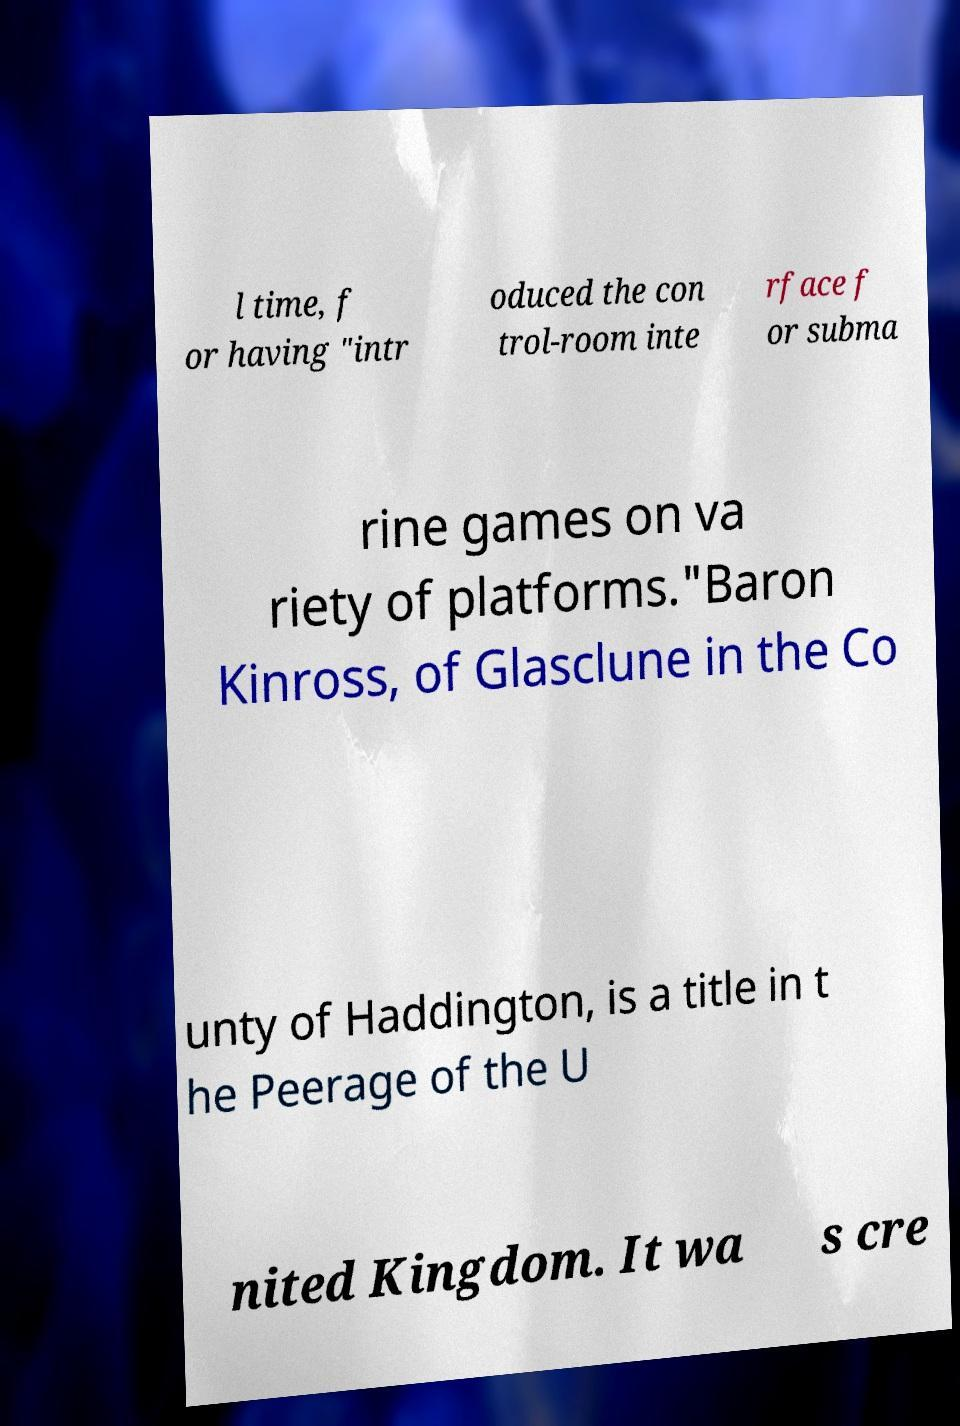What messages or text are displayed in this image? I need them in a readable, typed format. l time, f or having "intr oduced the con trol-room inte rface f or subma rine games on va riety of platforms."Baron Kinross, of Glasclune in the Co unty of Haddington, is a title in t he Peerage of the U nited Kingdom. It wa s cre 